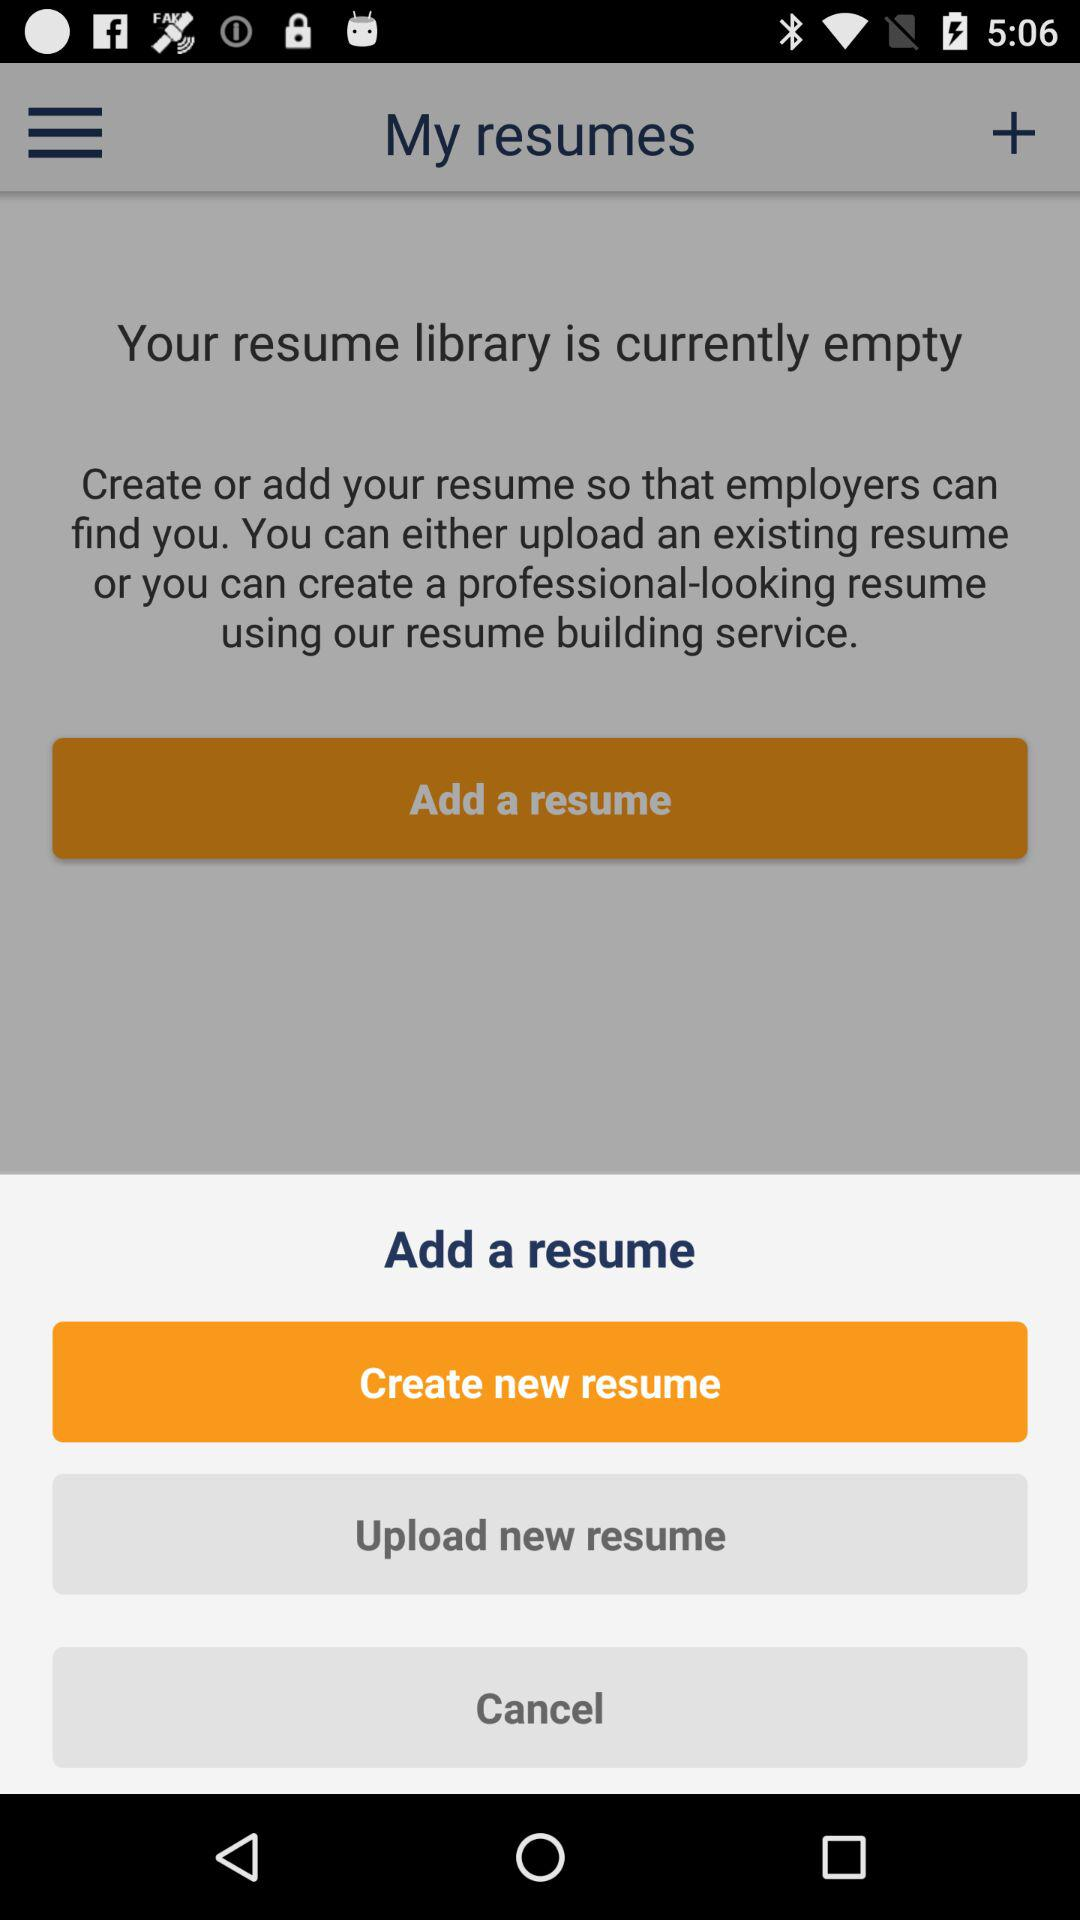Which option is selected? The selected option is "Add a resume". 